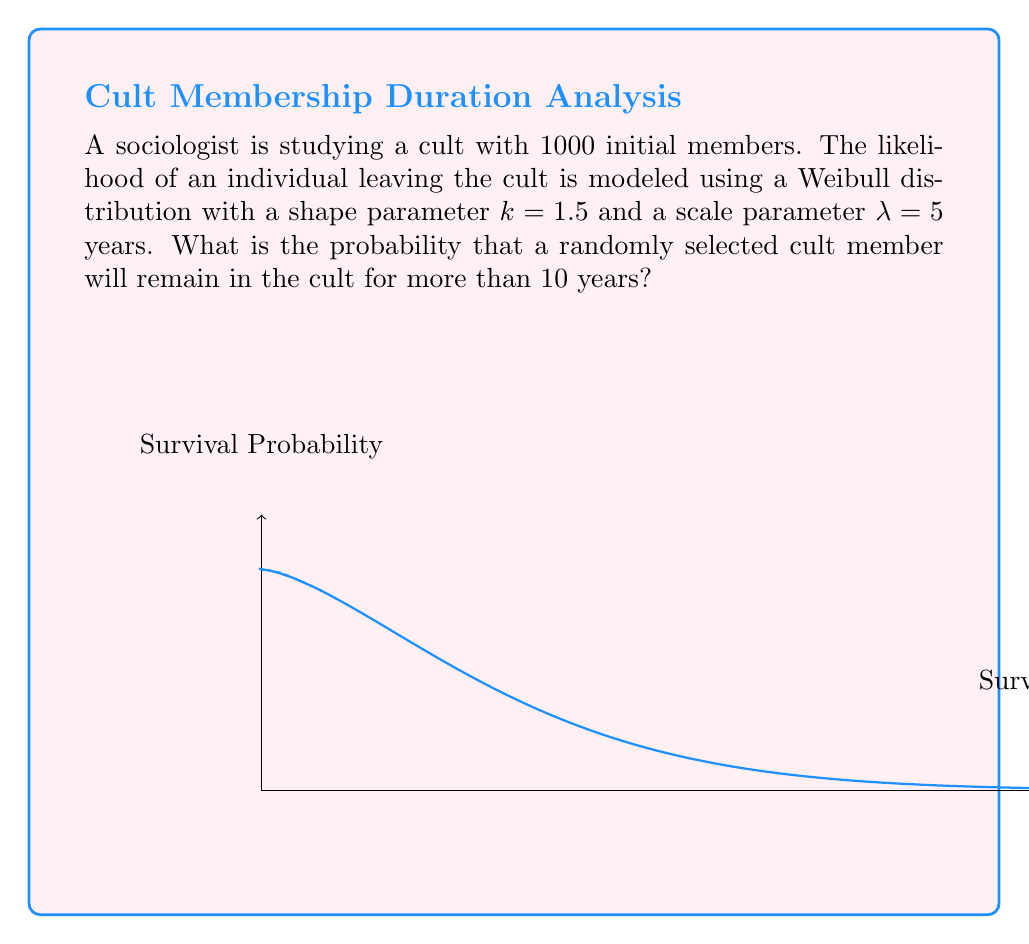Teach me how to tackle this problem. To solve this problem, we need to use the survival function of the Weibull distribution. The survival function $S(t)$ gives the probability that an individual survives (in this case, remains in the cult) beyond time $t$.

For a Weibull distribution with shape parameter $k$ and scale parameter $\lambda$, the survival function is:

$$S(t) = e^{-(\frac{t}{\lambda})^k}$$

Given:
- $k = 1.5$ (shape parameter)
- $\lambda = 5$ years (scale parameter)
- $t = 10$ years (time of interest)

Let's calculate the probability:

1) Substitute the values into the survival function:

   $$S(10) = e^{-(\frac{10}{5})^{1.5}}$$

2) Simplify inside the parentheses:

   $$S(10) = e^{-(2)^{1.5}}$$

3) Calculate the exponent:

   $$S(10) = e^{-2.8284}$$

4) Calculate the final value:

   $$S(10) \approx 0.0590$$

Therefore, the probability that a randomly selected cult member will remain in the cult for more than 10 years is approximately 0.0590 or 5.90%.
Answer: $0.0590$ or $5.90\%$ 